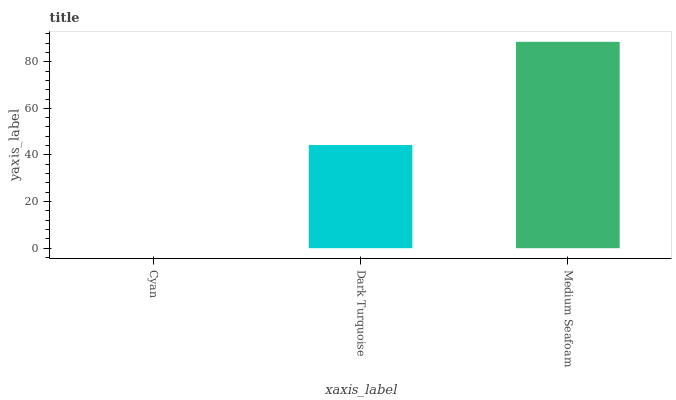Is Cyan the minimum?
Answer yes or no. Yes. Is Medium Seafoam the maximum?
Answer yes or no. Yes. Is Dark Turquoise the minimum?
Answer yes or no. No. Is Dark Turquoise the maximum?
Answer yes or no. No. Is Dark Turquoise greater than Cyan?
Answer yes or no. Yes. Is Cyan less than Dark Turquoise?
Answer yes or no. Yes. Is Cyan greater than Dark Turquoise?
Answer yes or no. No. Is Dark Turquoise less than Cyan?
Answer yes or no. No. Is Dark Turquoise the high median?
Answer yes or no. Yes. Is Dark Turquoise the low median?
Answer yes or no. Yes. Is Medium Seafoam the high median?
Answer yes or no. No. Is Cyan the low median?
Answer yes or no. No. 